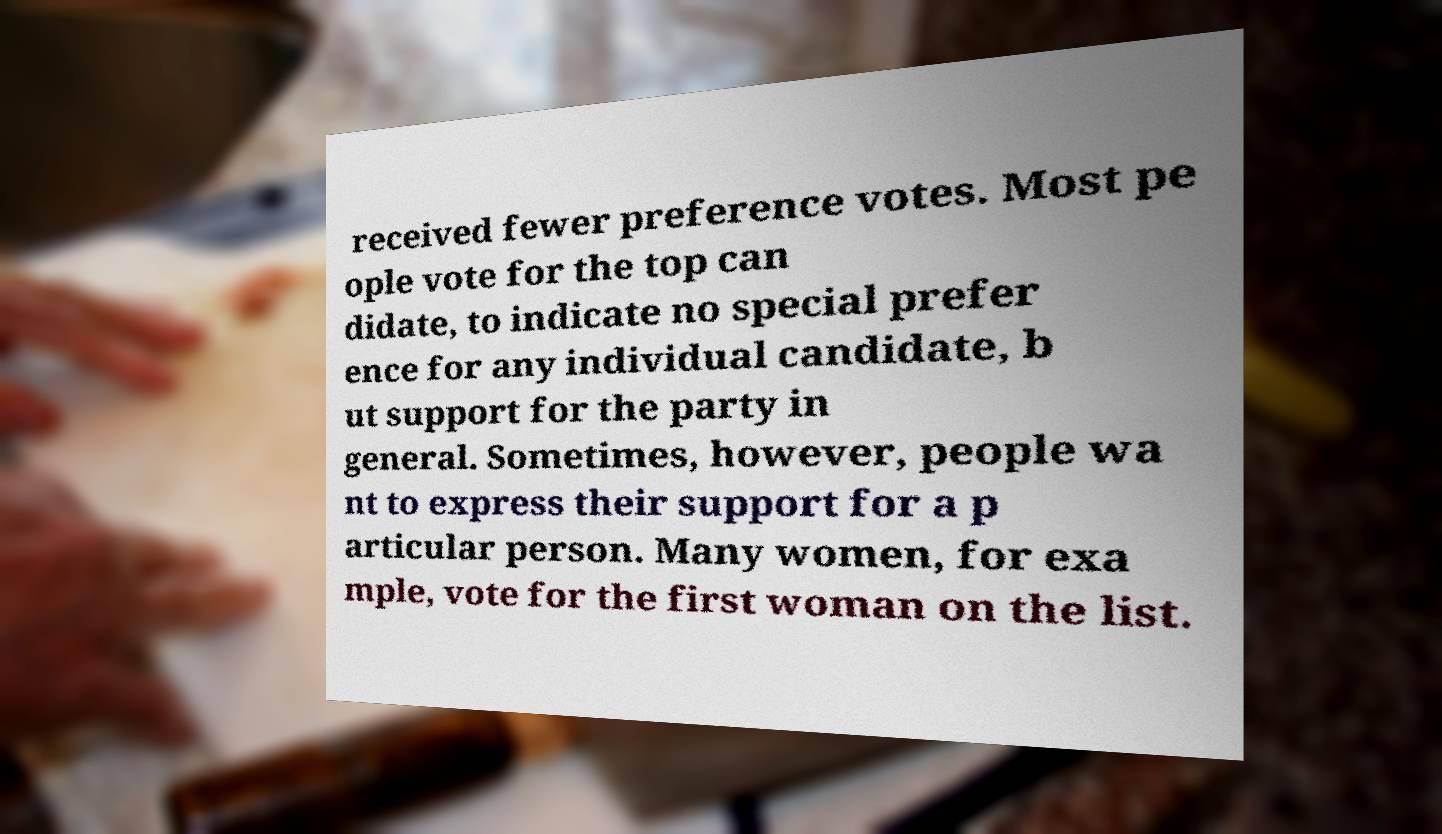For documentation purposes, I need the text within this image transcribed. Could you provide that? received fewer preference votes. Most pe ople vote for the top can didate, to indicate no special prefer ence for any individual candidate, b ut support for the party in general. Sometimes, however, people wa nt to express their support for a p articular person. Many women, for exa mple, vote for the first woman on the list. 